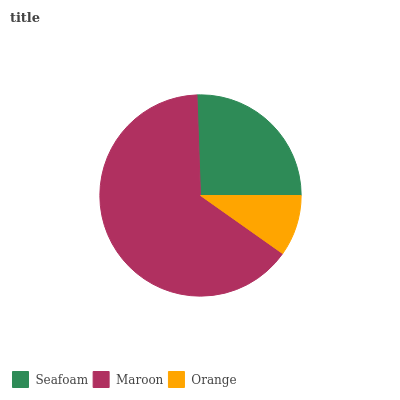Is Orange the minimum?
Answer yes or no. Yes. Is Maroon the maximum?
Answer yes or no. Yes. Is Maroon the minimum?
Answer yes or no. No. Is Orange the maximum?
Answer yes or no. No. Is Maroon greater than Orange?
Answer yes or no. Yes. Is Orange less than Maroon?
Answer yes or no. Yes. Is Orange greater than Maroon?
Answer yes or no. No. Is Maroon less than Orange?
Answer yes or no. No. Is Seafoam the high median?
Answer yes or no. Yes. Is Seafoam the low median?
Answer yes or no. Yes. Is Maroon the high median?
Answer yes or no. No. Is Orange the low median?
Answer yes or no. No. 